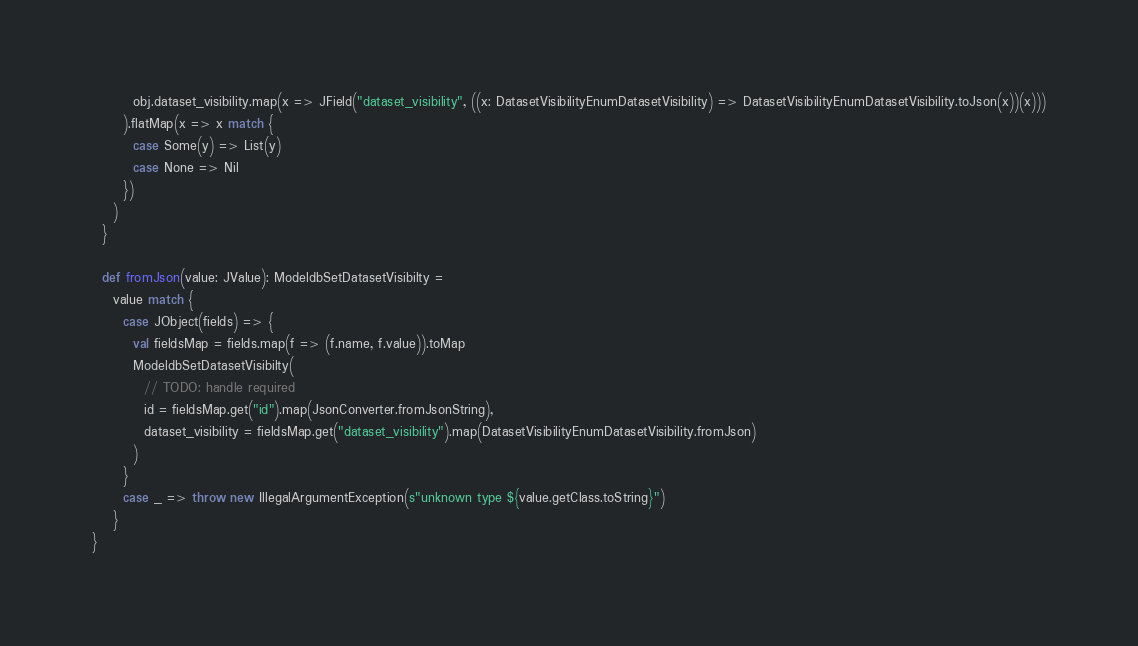<code> <loc_0><loc_0><loc_500><loc_500><_Scala_>        obj.dataset_visibility.map(x => JField("dataset_visibility", ((x: DatasetVisibilityEnumDatasetVisibility) => DatasetVisibilityEnumDatasetVisibility.toJson(x))(x)))
      ).flatMap(x => x match {
        case Some(y) => List(y)
        case None => Nil
      })
    )
  }

  def fromJson(value: JValue): ModeldbSetDatasetVisibilty =
    value match {
      case JObject(fields) => {
        val fieldsMap = fields.map(f => (f.name, f.value)).toMap
        ModeldbSetDatasetVisibilty(
          // TODO: handle required
          id = fieldsMap.get("id").map(JsonConverter.fromJsonString),
          dataset_visibility = fieldsMap.get("dataset_visibility").map(DatasetVisibilityEnumDatasetVisibility.fromJson)
        )
      }
      case _ => throw new IllegalArgumentException(s"unknown type ${value.getClass.toString}")
    }
}
</code> 